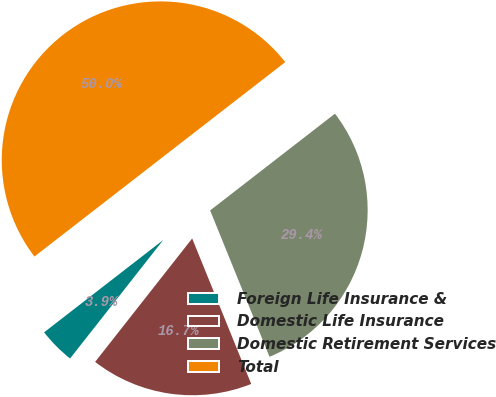Convert chart to OTSL. <chart><loc_0><loc_0><loc_500><loc_500><pie_chart><fcel>Foreign Life Insurance &<fcel>Domestic Life Insurance<fcel>Domestic Retirement Services<fcel>Total<nl><fcel>3.9%<fcel>16.74%<fcel>29.36%<fcel>50.0%<nl></chart> 